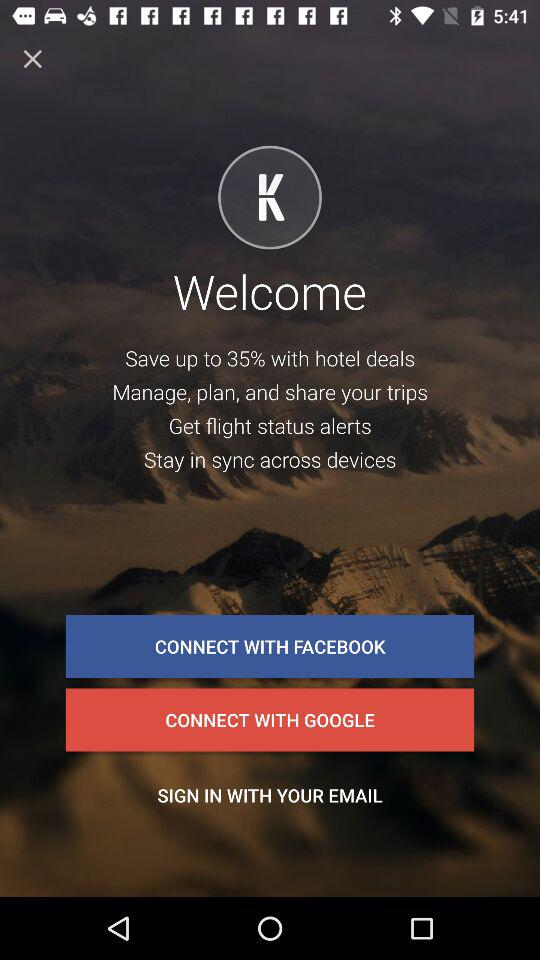Through which app can we connect? You can connect through "FACEBOOK" and "GOOGLE". 